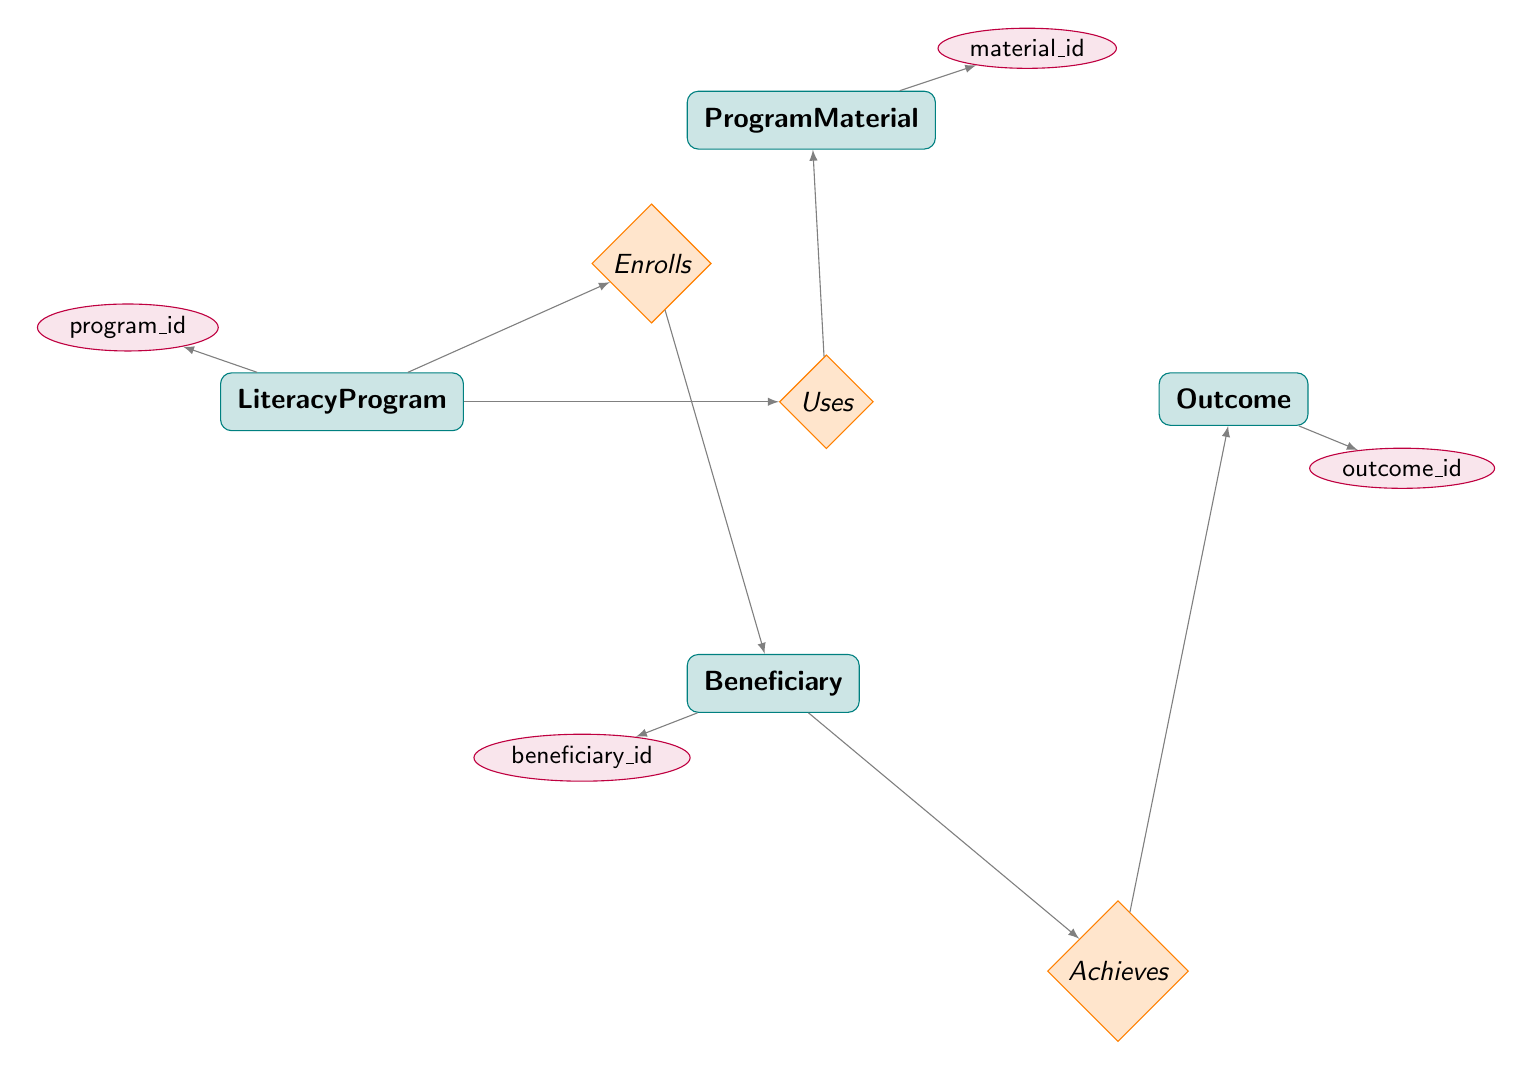What entities are present in the diagram? The diagram includes four entities: LiteracyProgram, Beneficiary, ProgramMaterial, and Outcome.
Answer: LiteracyProgram, Beneficiary, ProgramMaterial, Outcome How many relationships are represented in the diagram? The diagram features three relationships: Enrolls, Uses, and Achieves, linking the entities together.
Answer: 3 What attribute belongs to the LiteracyProgram entity? The LiteracyProgram entity includes attributes like program_id, name, description, start_date, and end_date. An example is program_id which uniquely identifies a program.
Answer: program_id What relationship exists between LiteracyProgram and Beneficiary? The relationship between LiteracyProgram and Beneficiary is labeled as "Enrolls," indicating that beneficiaries can enroll in literacy programs.
Answer: Enrolls What is the purpose of the Achieves relationship? The Achieves relationship signifies that beneficiaries can attain specific outcomes based on their participation in the literacy programs.
Answer: Indicates outcomes Which entity is connected to ProgramMaterial? The ProgramMaterial entity is connected to LiteracyProgram through the Uses relationship, showing that programs utilize specific materials.
Answer: LiteracyProgram Which attribute is associated with the Outcome entity? The Outcome entity includes the attribute outcome_id, which uniquely identifies each outcome achieved by a beneficiary after their participation in a program.
Answer: outcome_id How does a beneficiary achieve an outcome? A beneficiary achieves an outcome through the Achieves relationship, which links them directly to the Outcome entity, indicating the specific improvements made.
Answer: Through Achieves How many attributes does the Beneficiary entity have? The Beneficiary entity has five attributes: beneficiary_id, first_name, last_name, age, and location, describing personal details about the beneficiaries.
Answer: 5 